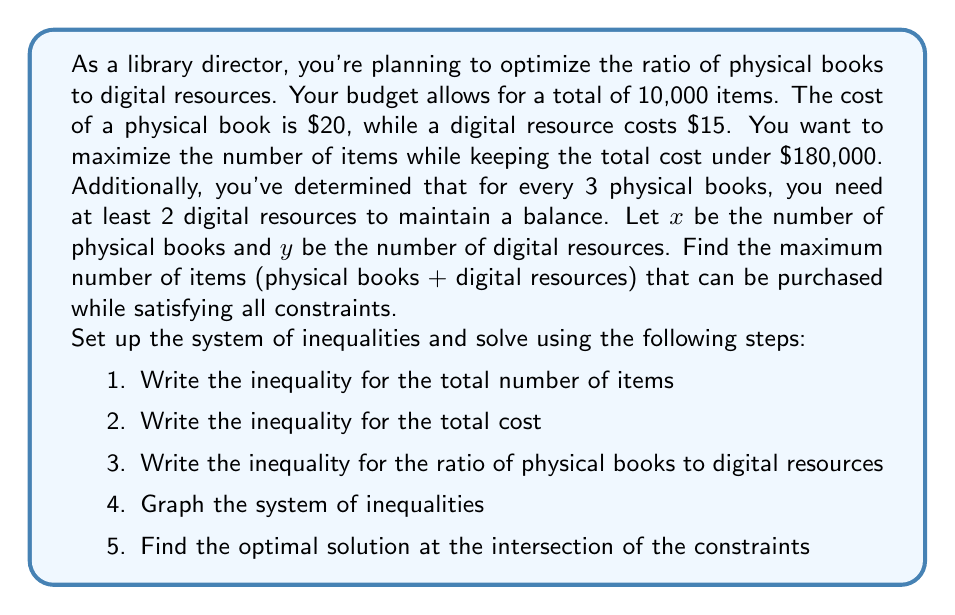What is the answer to this math problem? Let's approach this problem step by step:

1. Total number of items: 
   $x + y = 10,000$

2. Total cost constraint:
   $20x + 15y \leq 180,000$

3. Ratio constraint (for every 3 physical books, at least 2 digital resources):
   $\frac{y}{x} \geq \frac{2}{3}$ or $2x - 3y \leq 0$

Now, let's solve this system of inequalities:

4. Graphing the system:
   [asy]
   import graph;
   size(200,200);
   
   real f1(real x) {return 10000-x;}
   real f2(real x) {return (180000-20x)/15;}
   real f3(real x) {return (2/3)*x;}
   
   draw(graph(f1,0,10000),blue);
   draw(graph(f2,0,9000),red);
   draw(graph(f3,0,10000),green);
   
   label("x + y = 10,000",(5000,5000),N,blue);
   label("20x + 15y = 180,000",(4500,4000),NW,red);
   label("y = (2/3)x",(7500,5000),SE,green);
   
   dot((6000,4000),red);
   label("(6000, 4000)",(6000,4000),SE);
   
   xaxis("Physical Books (x)",0,10000,arrow=Arrow);
   yaxis("Digital Resources (y)",0,10000,arrow=Arrow);
   [/asy]

5. The optimal solution is at the intersection of $x + y = 10,000$ and $20x + 15y = 180,000$

Solving these equations simultaneously:

$x + y = 10,000$ ... (1)
$20x + 15y = 180,000$ ... (2)

Multiply (1) by 15: $15x + 15y = 150,000$ ... (3)
Subtract (3) from (2): $5x = 30,000$

Therefore, $x = 6,000$ and $y = 4,000$

We can verify that this satisfies the ratio constraint:
$\frac{y}{x} = \frac{4,000}{6,000} = \frac{2}{3}$

The maximum number of items that can be purchased is $6,000 + 4,000 = 10,000$.
Answer: The maximum number of items that can be purchased while satisfying all constraints is 10,000, consisting of 6,000 physical books and 4,000 digital resources. 